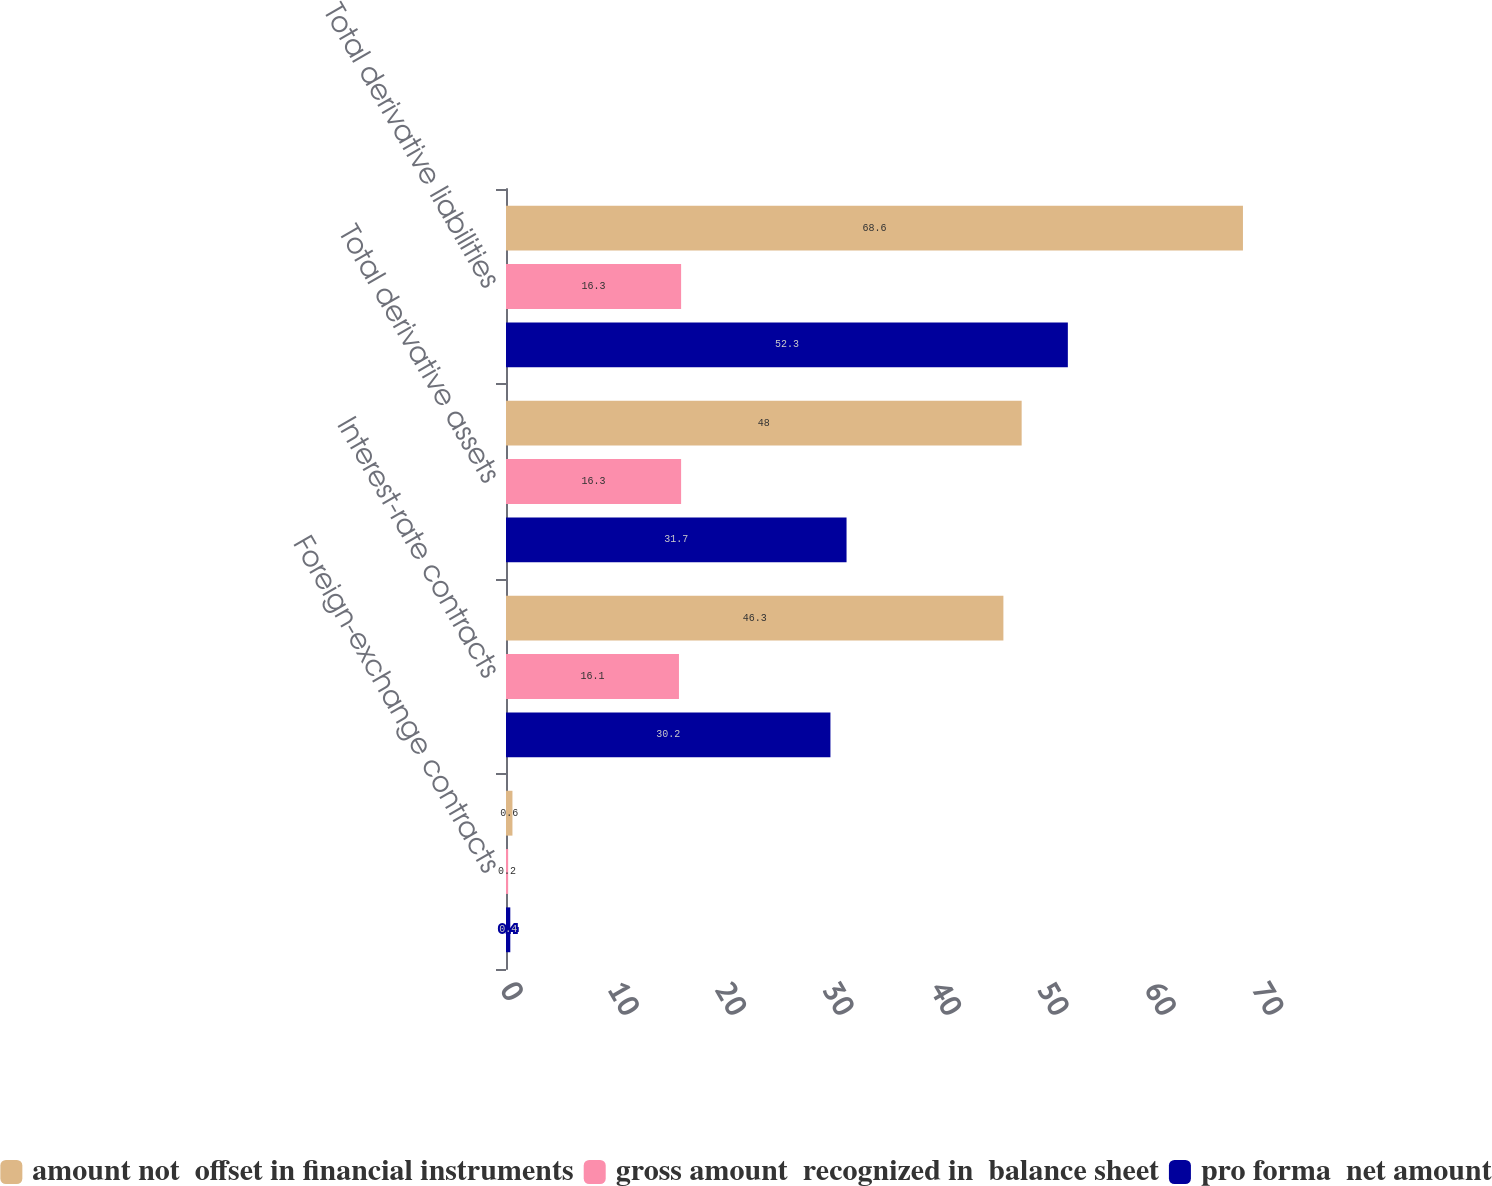Convert chart. <chart><loc_0><loc_0><loc_500><loc_500><stacked_bar_chart><ecel><fcel>Foreign-exchange contracts<fcel>Interest-rate contracts<fcel>Total derivative assets<fcel>Total derivative liabilities<nl><fcel>amount not  offset in financial instruments<fcel>0.6<fcel>46.3<fcel>48<fcel>68.6<nl><fcel>gross amount  recognized in  balance sheet<fcel>0.2<fcel>16.1<fcel>16.3<fcel>16.3<nl><fcel>pro forma  net amount<fcel>0.4<fcel>30.2<fcel>31.7<fcel>52.3<nl></chart> 